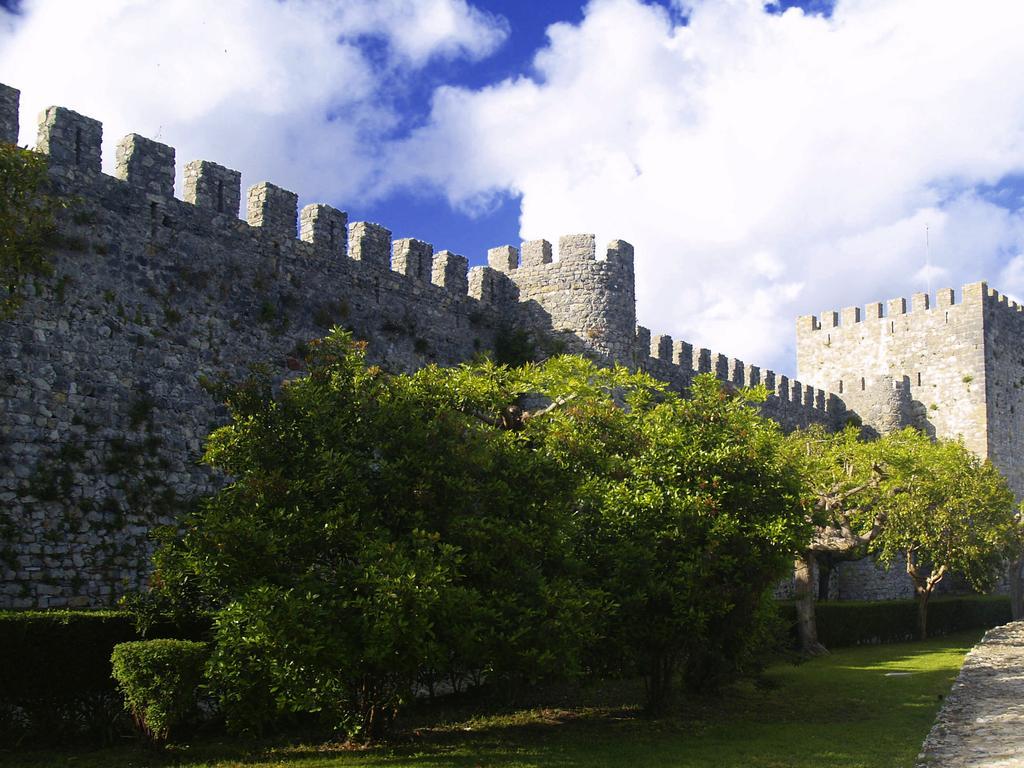Describe this image in one or two sentences. In this picture we can see trees in the front, at the bottom there is grass, in the background there is a fort, we can see the sky and clouds at the top of the picture. 